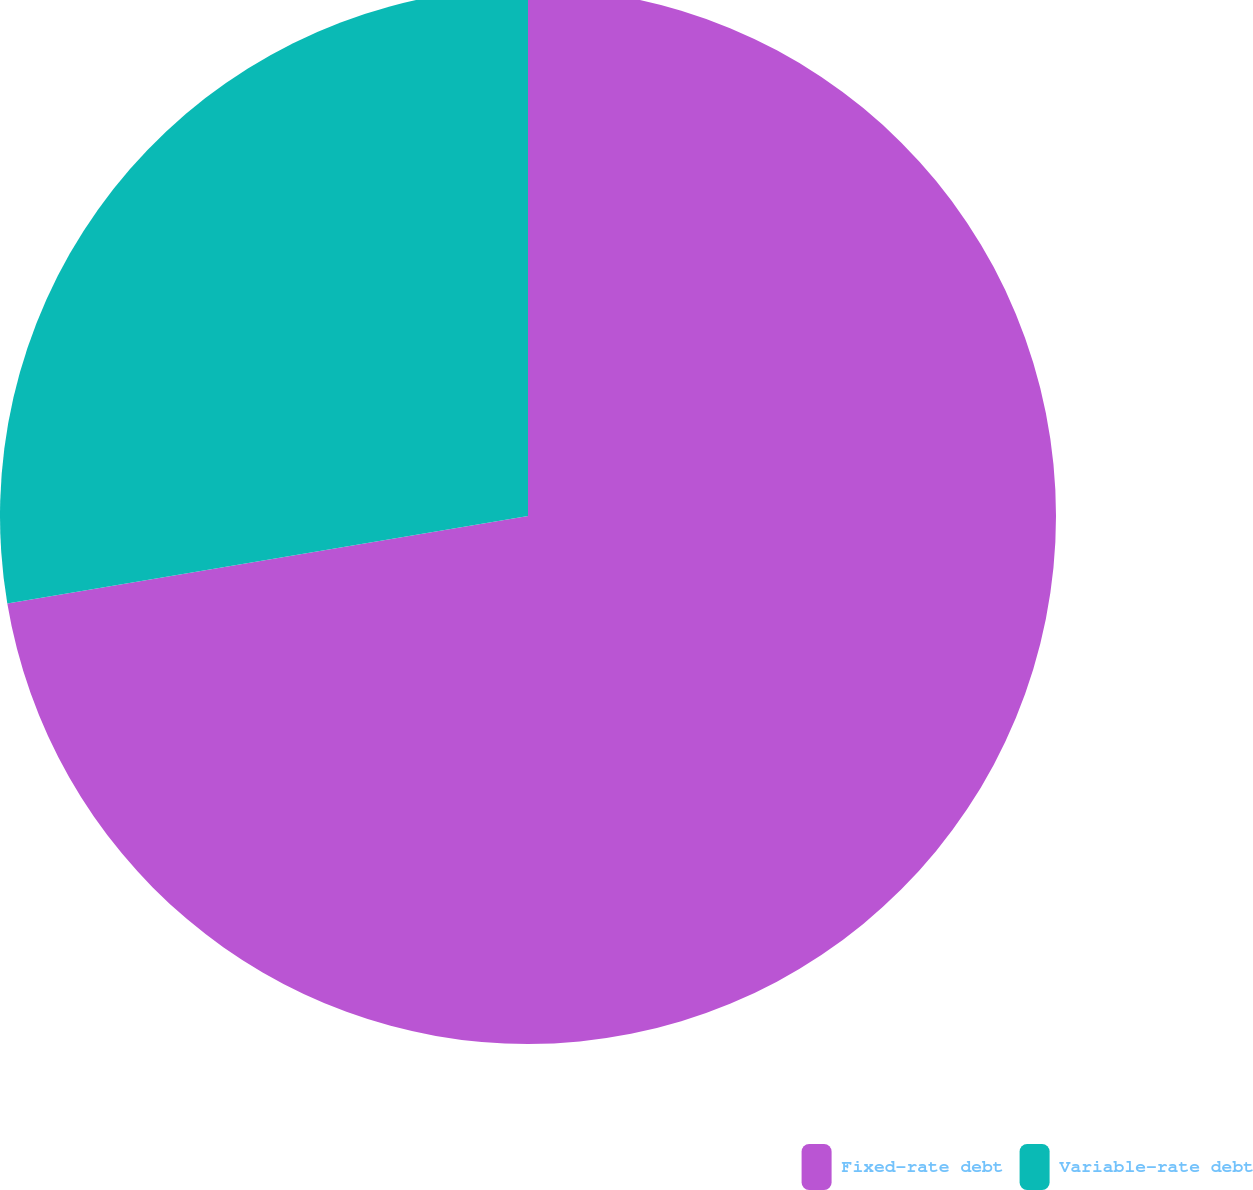<chart> <loc_0><loc_0><loc_500><loc_500><pie_chart><fcel>Fixed-rate debt<fcel>Variable-rate debt<nl><fcel>72.35%<fcel>27.65%<nl></chart> 